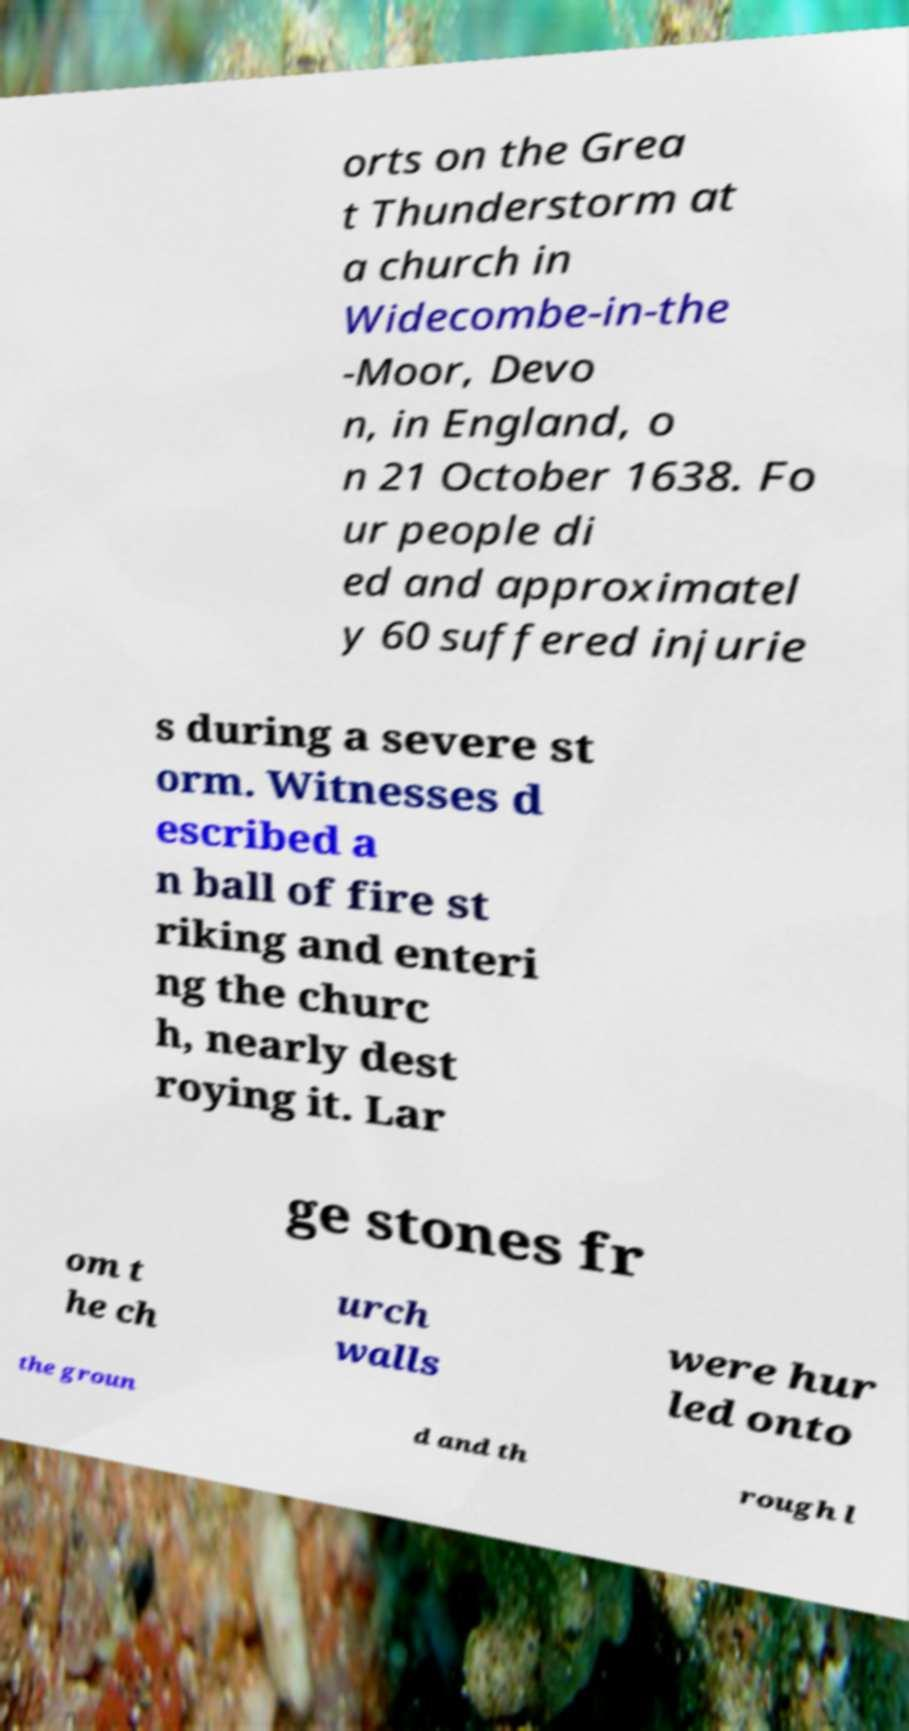Can you read and provide the text displayed in the image?This photo seems to have some interesting text. Can you extract and type it out for me? orts on the Grea t Thunderstorm at a church in Widecombe-in-the -Moor, Devo n, in England, o n 21 October 1638. Fo ur people di ed and approximatel y 60 suffered injurie s during a severe st orm. Witnesses d escribed a n ball of fire st riking and enteri ng the churc h, nearly dest roying it. Lar ge stones fr om t he ch urch walls were hur led onto the groun d and th rough l 